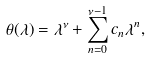Convert formula to latex. <formula><loc_0><loc_0><loc_500><loc_500>\theta ( \lambda ) = \lambda ^ { \nu } + \sum _ { n = 0 } ^ { \nu - 1 } c _ { n } \lambda ^ { n } ,</formula> 